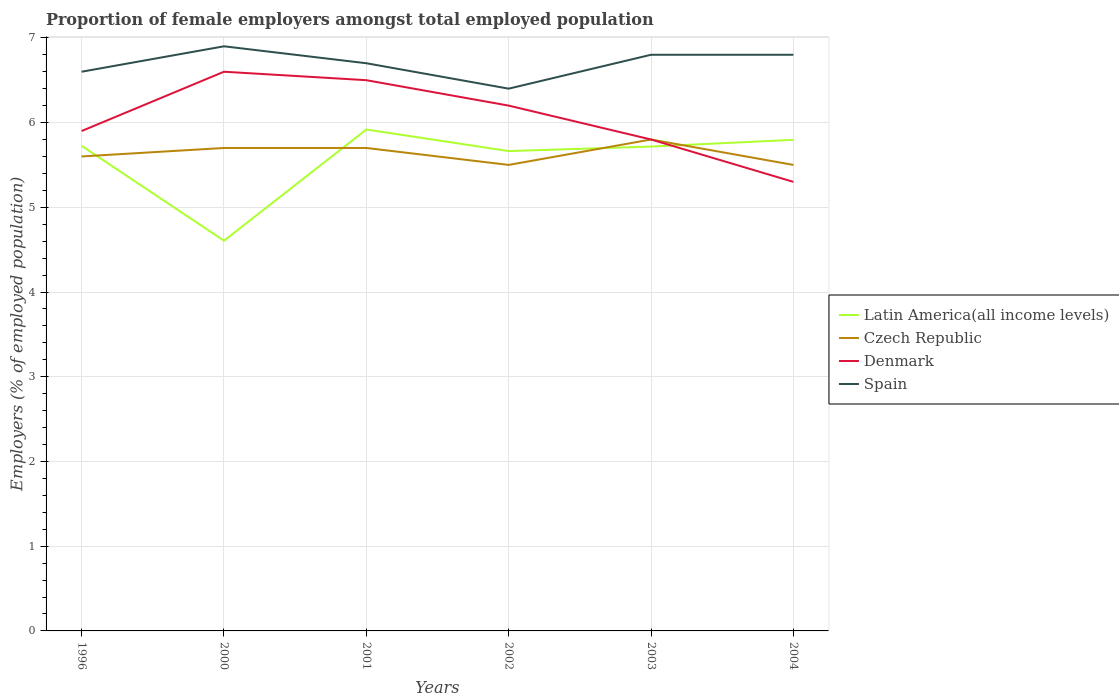Across all years, what is the maximum proportion of female employers in Denmark?
Keep it short and to the point. 5.3. In which year was the proportion of female employers in Denmark maximum?
Give a very brief answer. 2004. What is the total proportion of female employers in Czech Republic in the graph?
Your answer should be very brief. 0.2. What is the difference between the highest and the second highest proportion of female employers in Czech Republic?
Keep it short and to the point. 0.3. What is the difference between the highest and the lowest proportion of female employers in Spain?
Provide a short and direct response. 3. How many lines are there?
Your answer should be compact. 4. How many years are there in the graph?
Keep it short and to the point. 6. Does the graph contain any zero values?
Provide a short and direct response. No. How many legend labels are there?
Provide a short and direct response. 4. What is the title of the graph?
Provide a succinct answer. Proportion of female employers amongst total employed population. Does "Mali" appear as one of the legend labels in the graph?
Give a very brief answer. No. What is the label or title of the Y-axis?
Offer a terse response. Employers (% of employed population). What is the Employers (% of employed population) in Latin America(all income levels) in 1996?
Offer a very short reply. 5.73. What is the Employers (% of employed population) in Czech Republic in 1996?
Keep it short and to the point. 5.6. What is the Employers (% of employed population) in Denmark in 1996?
Offer a terse response. 5.9. What is the Employers (% of employed population) in Spain in 1996?
Give a very brief answer. 6.6. What is the Employers (% of employed population) of Latin America(all income levels) in 2000?
Offer a very short reply. 4.61. What is the Employers (% of employed population) of Czech Republic in 2000?
Provide a succinct answer. 5.7. What is the Employers (% of employed population) of Denmark in 2000?
Keep it short and to the point. 6.6. What is the Employers (% of employed population) of Spain in 2000?
Offer a very short reply. 6.9. What is the Employers (% of employed population) in Latin America(all income levels) in 2001?
Provide a short and direct response. 5.92. What is the Employers (% of employed population) in Czech Republic in 2001?
Ensure brevity in your answer.  5.7. What is the Employers (% of employed population) of Denmark in 2001?
Make the answer very short. 6.5. What is the Employers (% of employed population) in Spain in 2001?
Offer a terse response. 6.7. What is the Employers (% of employed population) of Latin America(all income levels) in 2002?
Ensure brevity in your answer.  5.66. What is the Employers (% of employed population) of Czech Republic in 2002?
Keep it short and to the point. 5.5. What is the Employers (% of employed population) of Denmark in 2002?
Give a very brief answer. 6.2. What is the Employers (% of employed population) in Spain in 2002?
Keep it short and to the point. 6.4. What is the Employers (% of employed population) of Latin America(all income levels) in 2003?
Your answer should be very brief. 5.72. What is the Employers (% of employed population) in Czech Republic in 2003?
Offer a very short reply. 5.8. What is the Employers (% of employed population) of Denmark in 2003?
Offer a terse response. 5.8. What is the Employers (% of employed population) of Spain in 2003?
Your answer should be compact. 6.8. What is the Employers (% of employed population) of Latin America(all income levels) in 2004?
Provide a short and direct response. 5.8. What is the Employers (% of employed population) of Czech Republic in 2004?
Your answer should be compact. 5.5. What is the Employers (% of employed population) in Denmark in 2004?
Your response must be concise. 5.3. What is the Employers (% of employed population) of Spain in 2004?
Offer a very short reply. 6.8. Across all years, what is the maximum Employers (% of employed population) of Latin America(all income levels)?
Your answer should be very brief. 5.92. Across all years, what is the maximum Employers (% of employed population) in Czech Republic?
Your response must be concise. 5.8. Across all years, what is the maximum Employers (% of employed population) of Denmark?
Make the answer very short. 6.6. Across all years, what is the maximum Employers (% of employed population) in Spain?
Provide a succinct answer. 6.9. Across all years, what is the minimum Employers (% of employed population) of Latin America(all income levels)?
Your answer should be compact. 4.61. Across all years, what is the minimum Employers (% of employed population) in Denmark?
Your answer should be compact. 5.3. Across all years, what is the minimum Employers (% of employed population) of Spain?
Your answer should be compact. 6.4. What is the total Employers (% of employed population) of Latin America(all income levels) in the graph?
Your answer should be very brief. 33.43. What is the total Employers (% of employed population) in Czech Republic in the graph?
Your answer should be very brief. 33.8. What is the total Employers (% of employed population) of Denmark in the graph?
Your response must be concise. 36.3. What is the total Employers (% of employed population) of Spain in the graph?
Offer a terse response. 40.2. What is the difference between the Employers (% of employed population) in Latin America(all income levels) in 1996 and that in 2000?
Your response must be concise. 1.12. What is the difference between the Employers (% of employed population) in Denmark in 1996 and that in 2000?
Keep it short and to the point. -0.7. What is the difference between the Employers (% of employed population) in Spain in 1996 and that in 2000?
Your response must be concise. -0.3. What is the difference between the Employers (% of employed population) of Latin America(all income levels) in 1996 and that in 2001?
Keep it short and to the point. -0.19. What is the difference between the Employers (% of employed population) in Denmark in 1996 and that in 2001?
Your response must be concise. -0.6. What is the difference between the Employers (% of employed population) in Latin America(all income levels) in 1996 and that in 2002?
Your answer should be compact. 0.06. What is the difference between the Employers (% of employed population) in Latin America(all income levels) in 1996 and that in 2003?
Your response must be concise. 0.01. What is the difference between the Employers (% of employed population) of Denmark in 1996 and that in 2003?
Keep it short and to the point. 0.1. What is the difference between the Employers (% of employed population) in Spain in 1996 and that in 2003?
Make the answer very short. -0.2. What is the difference between the Employers (% of employed population) in Latin America(all income levels) in 1996 and that in 2004?
Offer a terse response. -0.07. What is the difference between the Employers (% of employed population) in Denmark in 1996 and that in 2004?
Your response must be concise. 0.6. What is the difference between the Employers (% of employed population) in Latin America(all income levels) in 2000 and that in 2001?
Your answer should be compact. -1.31. What is the difference between the Employers (% of employed population) of Spain in 2000 and that in 2001?
Offer a very short reply. 0.2. What is the difference between the Employers (% of employed population) in Latin America(all income levels) in 2000 and that in 2002?
Keep it short and to the point. -1.06. What is the difference between the Employers (% of employed population) of Czech Republic in 2000 and that in 2002?
Offer a very short reply. 0.2. What is the difference between the Employers (% of employed population) of Denmark in 2000 and that in 2002?
Provide a succinct answer. 0.4. What is the difference between the Employers (% of employed population) in Latin America(all income levels) in 2000 and that in 2003?
Keep it short and to the point. -1.11. What is the difference between the Employers (% of employed population) of Latin America(all income levels) in 2000 and that in 2004?
Ensure brevity in your answer.  -1.19. What is the difference between the Employers (% of employed population) of Latin America(all income levels) in 2001 and that in 2002?
Give a very brief answer. 0.25. What is the difference between the Employers (% of employed population) of Denmark in 2001 and that in 2002?
Your response must be concise. 0.3. What is the difference between the Employers (% of employed population) in Latin America(all income levels) in 2001 and that in 2003?
Your answer should be compact. 0.2. What is the difference between the Employers (% of employed population) in Latin America(all income levels) in 2001 and that in 2004?
Keep it short and to the point. 0.12. What is the difference between the Employers (% of employed population) in Czech Republic in 2001 and that in 2004?
Provide a short and direct response. 0.2. What is the difference between the Employers (% of employed population) of Spain in 2001 and that in 2004?
Provide a succinct answer. -0.1. What is the difference between the Employers (% of employed population) in Latin America(all income levels) in 2002 and that in 2003?
Provide a succinct answer. -0.05. What is the difference between the Employers (% of employed population) in Czech Republic in 2002 and that in 2003?
Keep it short and to the point. -0.3. What is the difference between the Employers (% of employed population) of Spain in 2002 and that in 2003?
Ensure brevity in your answer.  -0.4. What is the difference between the Employers (% of employed population) of Latin America(all income levels) in 2002 and that in 2004?
Keep it short and to the point. -0.13. What is the difference between the Employers (% of employed population) in Denmark in 2002 and that in 2004?
Your response must be concise. 0.9. What is the difference between the Employers (% of employed population) of Latin America(all income levels) in 2003 and that in 2004?
Your answer should be very brief. -0.08. What is the difference between the Employers (% of employed population) in Latin America(all income levels) in 1996 and the Employers (% of employed population) in Czech Republic in 2000?
Your answer should be very brief. 0.03. What is the difference between the Employers (% of employed population) of Latin America(all income levels) in 1996 and the Employers (% of employed population) of Denmark in 2000?
Offer a very short reply. -0.87. What is the difference between the Employers (% of employed population) in Latin America(all income levels) in 1996 and the Employers (% of employed population) in Spain in 2000?
Offer a terse response. -1.17. What is the difference between the Employers (% of employed population) in Czech Republic in 1996 and the Employers (% of employed population) in Spain in 2000?
Your answer should be very brief. -1.3. What is the difference between the Employers (% of employed population) of Denmark in 1996 and the Employers (% of employed population) of Spain in 2000?
Your answer should be very brief. -1. What is the difference between the Employers (% of employed population) of Latin America(all income levels) in 1996 and the Employers (% of employed population) of Czech Republic in 2001?
Provide a succinct answer. 0.03. What is the difference between the Employers (% of employed population) in Latin America(all income levels) in 1996 and the Employers (% of employed population) in Denmark in 2001?
Provide a short and direct response. -0.77. What is the difference between the Employers (% of employed population) in Latin America(all income levels) in 1996 and the Employers (% of employed population) in Spain in 2001?
Give a very brief answer. -0.97. What is the difference between the Employers (% of employed population) of Czech Republic in 1996 and the Employers (% of employed population) of Denmark in 2001?
Offer a very short reply. -0.9. What is the difference between the Employers (% of employed population) of Latin America(all income levels) in 1996 and the Employers (% of employed population) of Czech Republic in 2002?
Ensure brevity in your answer.  0.23. What is the difference between the Employers (% of employed population) in Latin America(all income levels) in 1996 and the Employers (% of employed population) in Denmark in 2002?
Keep it short and to the point. -0.47. What is the difference between the Employers (% of employed population) of Latin America(all income levels) in 1996 and the Employers (% of employed population) of Spain in 2002?
Make the answer very short. -0.67. What is the difference between the Employers (% of employed population) of Czech Republic in 1996 and the Employers (% of employed population) of Spain in 2002?
Your answer should be very brief. -0.8. What is the difference between the Employers (% of employed population) in Denmark in 1996 and the Employers (% of employed population) in Spain in 2002?
Provide a succinct answer. -0.5. What is the difference between the Employers (% of employed population) of Latin America(all income levels) in 1996 and the Employers (% of employed population) of Czech Republic in 2003?
Keep it short and to the point. -0.07. What is the difference between the Employers (% of employed population) of Latin America(all income levels) in 1996 and the Employers (% of employed population) of Denmark in 2003?
Your answer should be compact. -0.07. What is the difference between the Employers (% of employed population) in Latin America(all income levels) in 1996 and the Employers (% of employed population) in Spain in 2003?
Your answer should be very brief. -1.07. What is the difference between the Employers (% of employed population) of Czech Republic in 1996 and the Employers (% of employed population) of Spain in 2003?
Your answer should be compact. -1.2. What is the difference between the Employers (% of employed population) in Latin America(all income levels) in 1996 and the Employers (% of employed population) in Czech Republic in 2004?
Provide a succinct answer. 0.23. What is the difference between the Employers (% of employed population) of Latin America(all income levels) in 1996 and the Employers (% of employed population) of Denmark in 2004?
Offer a terse response. 0.43. What is the difference between the Employers (% of employed population) in Latin America(all income levels) in 1996 and the Employers (% of employed population) in Spain in 2004?
Make the answer very short. -1.07. What is the difference between the Employers (% of employed population) of Latin America(all income levels) in 2000 and the Employers (% of employed population) of Czech Republic in 2001?
Offer a very short reply. -1.09. What is the difference between the Employers (% of employed population) in Latin America(all income levels) in 2000 and the Employers (% of employed population) in Denmark in 2001?
Keep it short and to the point. -1.89. What is the difference between the Employers (% of employed population) of Latin America(all income levels) in 2000 and the Employers (% of employed population) of Spain in 2001?
Your answer should be compact. -2.09. What is the difference between the Employers (% of employed population) in Czech Republic in 2000 and the Employers (% of employed population) in Spain in 2001?
Provide a succinct answer. -1. What is the difference between the Employers (% of employed population) of Latin America(all income levels) in 2000 and the Employers (% of employed population) of Czech Republic in 2002?
Ensure brevity in your answer.  -0.89. What is the difference between the Employers (% of employed population) in Latin America(all income levels) in 2000 and the Employers (% of employed population) in Denmark in 2002?
Offer a very short reply. -1.59. What is the difference between the Employers (% of employed population) of Latin America(all income levels) in 2000 and the Employers (% of employed population) of Spain in 2002?
Provide a short and direct response. -1.79. What is the difference between the Employers (% of employed population) of Czech Republic in 2000 and the Employers (% of employed population) of Denmark in 2002?
Ensure brevity in your answer.  -0.5. What is the difference between the Employers (% of employed population) in Czech Republic in 2000 and the Employers (% of employed population) in Spain in 2002?
Give a very brief answer. -0.7. What is the difference between the Employers (% of employed population) of Denmark in 2000 and the Employers (% of employed population) of Spain in 2002?
Ensure brevity in your answer.  0.2. What is the difference between the Employers (% of employed population) in Latin America(all income levels) in 2000 and the Employers (% of employed population) in Czech Republic in 2003?
Give a very brief answer. -1.19. What is the difference between the Employers (% of employed population) of Latin America(all income levels) in 2000 and the Employers (% of employed population) of Denmark in 2003?
Make the answer very short. -1.19. What is the difference between the Employers (% of employed population) in Latin America(all income levels) in 2000 and the Employers (% of employed population) in Spain in 2003?
Provide a succinct answer. -2.19. What is the difference between the Employers (% of employed population) in Czech Republic in 2000 and the Employers (% of employed population) in Denmark in 2003?
Your answer should be compact. -0.1. What is the difference between the Employers (% of employed population) of Latin America(all income levels) in 2000 and the Employers (% of employed population) of Czech Republic in 2004?
Offer a very short reply. -0.89. What is the difference between the Employers (% of employed population) of Latin America(all income levels) in 2000 and the Employers (% of employed population) of Denmark in 2004?
Your response must be concise. -0.69. What is the difference between the Employers (% of employed population) of Latin America(all income levels) in 2000 and the Employers (% of employed population) of Spain in 2004?
Give a very brief answer. -2.19. What is the difference between the Employers (% of employed population) of Czech Republic in 2000 and the Employers (% of employed population) of Denmark in 2004?
Keep it short and to the point. 0.4. What is the difference between the Employers (% of employed population) in Latin America(all income levels) in 2001 and the Employers (% of employed population) in Czech Republic in 2002?
Your response must be concise. 0.42. What is the difference between the Employers (% of employed population) in Latin America(all income levels) in 2001 and the Employers (% of employed population) in Denmark in 2002?
Offer a very short reply. -0.28. What is the difference between the Employers (% of employed population) in Latin America(all income levels) in 2001 and the Employers (% of employed population) in Spain in 2002?
Your answer should be compact. -0.48. What is the difference between the Employers (% of employed population) in Czech Republic in 2001 and the Employers (% of employed population) in Spain in 2002?
Offer a very short reply. -0.7. What is the difference between the Employers (% of employed population) in Latin America(all income levels) in 2001 and the Employers (% of employed population) in Czech Republic in 2003?
Your answer should be very brief. 0.12. What is the difference between the Employers (% of employed population) in Latin America(all income levels) in 2001 and the Employers (% of employed population) in Denmark in 2003?
Keep it short and to the point. 0.12. What is the difference between the Employers (% of employed population) in Latin America(all income levels) in 2001 and the Employers (% of employed population) in Spain in 2003?
Ensure brevity in your answer.  -0.88. What is the difference between the Employers (% of employed population) in Czech Republic in 2001 and the Employers (% of employed population) in Spain in 2003?
Offer a terse response. -1.1. What is the difference between the Employers (% of employed population) in Latin America(all income levels) in 2001 and the Employers (% of employed population) in Czech Republic in 2004?
Offer a very short reply. 0.42. What is the difference between the Employers (% of employed population) in Latin America(all income levels) in 2001 and the Employers (% of employed population) in Denmark in 2004?
Your response must be concise. 0.62. What is the difference between the Employers (% of employed population) in Latin America(all income levels) in 2001 and the Employers (% of employed population) in Spain in 2004?
Offer a very short reply. -0.88. What is the difference between the Employers (% of employed population) in Czech Republic in 2001 and the Employers (% of employed population) in Denmark in 2004?
Give a very brief answer. 0.4. What is the difference between the Employers (% of employed population) in Latin America(all income levels) in 2002 and the Employers (% of employed population) in Czech Republic in 2003?
Ensure brevity in your answer.  -0.14. What is the difference between the Employers (% of employed population) in Latin America(all income levels) in 2002 and the Employers (% of employed population) in Denmark in 2003?
Give a very brief answer. -0.14. What is the difference between the Employers (% of employed population) of Latin America(all income levels) in 2002 and the Employers (% of employed population) of Spain in 2003?
Your response must be concise. -1.14. What is the difference between the Employers (% of employed population) of Czech Republic in 2002 and the Employers (% of employed population) of Spain in 2003?
Offer a very short reply. -1.3. What is the difference between the Employers (% of employed population) of Latin America(all income levels) in 2002 and the Employers (% of employed population) of Czech Republic in 2004?
Give a very brief answer. 0.16. What is the difference between the Employers (% of employed population) in Latin America(all income levels) in 2002 and the Employers (% of employed population) in Denmark in 2004?
Offer a very short reply. 0.36. What is the difference between the Employers (% of employed population) in Latin America(all income levels) in 2002 and the Employers (% of employed population) in Spain in 2004?
Offer a terse response. -1.14. What is the difference between the Employers (% of employed population) of Latin America(all income levels) in 2003 and the Employers (% of employed population) of Czech Republic in 2004?
Your answer should be very brief. 0.22. What is the difference between the Employers (% of employed population) of Latin America(all income levels) in 2003 and the Employers (% of employed population) of Denmark in 2004?
Ensure brevity in your answer.  0.42. What is the difference between the Employers (% of employed population) of Latin America(all income levels) in 2003 and the Employers (% of employed population) of Spain in 2004?
Offer a terse response. -1.08. What is the difference between the Employers (% of employed population) in Denmark in 2003 and the Employers (% of employed population) in Spain in 2004?
Make the answer very short. -1. What is the average Employers (% of employed population) of Latin America(all income levels) per year?
Make the answer very short. 5.57. What is the average Employers (% of employed population) in Czech Republic per year?
Offer a very short reply. 5.63. What is the average Employers (% of employed population) of Denmark per year?
Ensure brevity in your answer.  6.05. What is the average Employers (% of employed population) of Spain per year?
Ensure brevity in your answer.  6.7. In the year 1996, what is the difference between the Employers (% of employed population) in Latin America(all income levels) and Employers (% of employed population) in Czech Republic?
Provide a short and direct response. 0.13. In the year 1996, what is the difference between the Employers (% of employed population) in Latin America(all income levels) and Employers (% of employed population) in Denmark?
Offer a very short reply. -0.17. In the year 1996, what is the difference between the Employers (% of employed population) in Latin America(all income levels) and Employers (% of employed population) in Spain?
Your response must be concise. -0.87. In the year 1996, what is the difference between the Employers (% of employed population) in Czech Republic and Employers (% of employed population) in Denmark?
Your response must be concise. -0.3. In the year 1996, what is the difference between the Employers (% of employed population) of Denmark and Employers (% of employed population) of Spain?
Provide a succinct answer. -0.7. In the year 2000, what is the difference between the Employers (% of employed population) of Latin America(all income levels) and Employers (% of employed population) of Czech Republic?
Make the answer very short. -1.09. In the year 2000, what is the difference between the Employers (% of employed population) in Latin America(all income levels) and Employers (% of employed population) in Denmark?
Make the answer very short. -1.99. In the year 2000, what is the difference between the Employers (% of employed population) of Latin America(all income levels) and Employers (% of employed population) of Spain?
Your answer should be compact. -2.29. In the year 2000, what is the difference between the Employers (% of employed population) of Czech Republic and Employers (% of employed population) of Denmark?
Ensure brevity in your answer.  -0.9. In the year 2000, what is the difference between the Employers (% of employed population) of Denmark and Employers (% of employed population) of Spain?
Keep it short and to the point. -0.3. In the year 2001, what is the difference between the Employers (% of employed population) of Latin America(all income levels) and Employers (% of employed population) of Czech Republic?
Ensure brevity in your answer.  0.22. In the year 2001, what is the difference between the Employers (% of employed population) of Latin America(all income levels) and Employers (% of employed population) of Denmark?
Provide a succinct answer. -0.58. In the year 2001, what is the difference between the Employers (% of employed population) in Latin America(all income levels) and Employers (% of employed population) in Spain?
Provide a short and direct response. -0.78. In the year 2001, what is the difference between the Employers (% of employed population) of Czech Republic and Employers (% of employed population) of Denmark?
Make the answer very short. -0.8. In the year 2001, what is the difference between the Employers (% of employed population) in Czech Republic and Employers (% of employed population) in Spain?
Offer a terse response. -1. In the year 2002, what is the difference between the Employers (% of employed population) of Latin America(all income levels) and Employers (% of employed population) of Czech Republic?
Offer a terse response. 0.16. In the year 2002, what is the difference between the Employers (% of employed population) in Latin America(all income levels) and Employers (% of employed population) in Denmark?
Make the answer very short. -0.54. In the year 2002, what is the difference between the Employers (% of employed population) in Latin America(all income levels) and Employers (% of employed population) in Spain?
Your response must be concise. -0.74. In the year 2002, what is the difference between the Employers (% of employed population) of Czech Republic and Employers (% of employed population) of Denmark?
Keep it short and to the point. -0.7. In the year 2002, what is the difference between the Employers (% of employed population) in Denmark and Employers (% of employed population) in Spain?
Give a very brief answer. -0.2. In the year 2003, what is the difference between the Employers (% of employed population) of Latin America(all income levels) and Employers (% of employed population) of Czech Republic?
Make the answer very short. -0.08. In the year 2003, what is the difference between the Employers (% of employed population) in Latin America(all income levels) and Employers (% of employed population) in Denmark?
Ensure brevity in your answer.  -0.08. In the year 2003, what is the difference between the Employers (% of employed population) of Latin America(all income levels) and Employers (% of employed population) of Spain?
Provide a short and direct response. -1.08. In the year 2003, what is the difference between the Employers (% of employed population) of Czech Republic and Employers (% of employed population) of Denmark?
Your answer should be very brief. 0. In the year 2003, what is the difference between the Employers (% of employed population) of Denmark and Employers (% of employed population) of Spain?
Make the answer very short. -1. In the year 2004, what is the difference between the Employers (% of employed population) in Latin America(all income levels) and Employers (% of employed population) in Czech Republic?
Offer a very short reply. 0.3. In the year 2004, what is the difference between the Employers (% of employed population) of Latin America(all income levels) and Employers (% of employed population) of Denmark?
Your response must be concise. 0.5. In the year 2004, what is the difference between the Employers (% of employed population) of Latin America(all income levels) and Employers (% of employed population) of Spain?
Provide a succinct answer. -1. What is the ratio of the Employers (% of employed population) of Latin America(all income levels) in 1996 to that in 2000?
Give a very brief answer. 1.24. What is the ratio of the Employers (% of employed population) in Czech Republic in 1996 to that in 2000?
Provide a short and direct response. 0.98. What is the ratio of the Employers (% of employed population) of Denmark in 1996 to that in 2000?
Provide a succinct answer. 0.89. What is the ratio of the Employers (% of employed population) in Spain in 1996 to that in 2000?
Give a very brief answer. 0.96. What is the ratio of the Employers (% of employed population) in Latin America(all income levels) in 1996 to that in 2001?
Keep it short and to the point. 0.97. What is the ratio of the Employers (% of employed population) of Czech Republic in 1996 to that in 2001?
Ensure brevity in your answer.  0.98. What is the ratio of the Employers (% of employed population) of Denmark in 1996 to that in 2001?
Ensure brevity in your answer.  0.91. What is the ratio of the Employers (% of employed population) in Spain in 1996 to that in 2001?
Provide a short and direct response. 0.99. What is the ratio of the Employers (% of employed population) in Czech Republic in 1996 to that in 2002?
Your response must be concise. 1.02. What is the ratio of the Employers (% of employed population) of Denmark in 1996 to that in 2002?
Ensure brevity in your answer.  0.95. What is the ratio of the Employers (% of employed population) of Spain in 1996 to that in 2002?
Make the answer very short. 1.03. What is the ratio of the Employers (% of employed population) in Czech Republic in 1996 to that in 2003?
Your answer should be very brief. 0.97. What is the ratio of the Employers (% of employed population) in Denmark in 1996 to that in 2003?
Provide a short and direct response. 1.02. What is the ratio of the Employers (% of employed population) in Spain in 1996 to that in 2003?
Provide a short and direct response. 0.97. What is the ratio of the Employers (% of employed population) of Latin America(all income levels) in 1996 to that in 2004?
Make the answer very short. 0.99. What is the ratio of the Employers (% of employed population) of Czech Republic in 1996 to that in 2004?
Your answer should be very brief. 1.02. What is the ratio of the Employers (% of employed population) of Denmark in 1996 to that in 2004?
Your answer should be compact. 1.11. What is the ratio of the Employers (% of employed population) in Spain in 1996 to that in 2004?
Your answer should be very brief. 0.97. What is the ratio of the Employers (% of employed population) in Latin America(all income levels) in 2000 to that in 2001?
Keep it short and to the point. 0.78. What is the ratio of the Employers (% of employed population) in Czech Republic in 2000 to that in 2001?
Provide a succinct answer. 1. What is the ratio of the Employers (% of employed population) of Denmark in 2000 to that in 2001?
Give a very brief answer. 1.02. What is the ratio of the Employers (% of employed population) of Spain in 2000 to that in 2001?
Make the answer very short. 1.03. What is the ratio of the Employers (% of employed population) in Latin America(all income levels) in 2000 to that in 2002?
Keep it short and to the point. 0.81. What is the ratio of the Employers (% of employed population) in Czech Republic in 2000 to that in 2002?
Offer a terse response. 1.04. What is the ratio of the Employers (% of employed population) of Denmark in 2000 to that in 2002?
Provide a succinct answer. 1.06. What is the ratio of the Employers (% of employed population) of Spain in 2000 to that in 2002?
Offer a terse response. 1.08. What is the ratio of the Employers (% of employed population) of Latin America(all income levels) in 2000 to that in 2003?
Ensure brevity in your answer.  0.81. What is the ratio of the Employers (% of employed population) in Czech Republic in 2000 to that in 2003?
Give a very brief answer. 0.98. What is the ratio of the Employers (% of employed population) in Denmark in 2000 to that in 2003?
Offer a terse response. 1.14. What is the ratio of the Employers (% of employed population) in Spain in 2000 to that in 2003?
Offer a very short reply. 1.01. What is the ratio of the Employers (% of employed population) in Latin America(all income levels) in 2000 to that in 2004?
Offer a terse response. 0.79. What is the ratio of the Employers (% of employed population) in Czech Republic in 2000 to that in 2004?
Your answer should be compact. 1.04. What is the ratio of the Employers (% of employed population) in Denmark in 2000 to that in 2004?
Your answer should be compact. 1.25. What is the ratio of the Employers (% of employed population) in Spain in 2000 to that in 2004?
Offer a terse response. 1.01. What is the ratio of the Employers (% of employed population) in Latin America(all income levels) in 2001 to that in 2002?
Your answer should be compact. 1.04. What is the ratio of the Employers (% of employed population) in Czech Republic in 2001 to that in 2002?
Offer a terse response. 1.04. What is the ratio of the Employers (% of employed population) of Denmark in 2001 to that in 2002?
Give a very brief answer. 1.05. What is the ratio of the Employers (% of employed population) of Spain in 2001 to that in 2002?
Provide a succinct answer. 1.05. What is the ratio of the Employers (% of employed population) in Latin America(all income levels) in 2001 to that in 2003?
Your answer should be compact. 1.04. What is the ratio of the Employers (% of employed population) of Czech Republic in 2001 to that in 2003?
Offer a terse response. 0.98. What is the ratio of the Employers (% of employed population) in Denmark in 2001 to that in 2003?
Provide a short and direct response. 1.12. What is the ratio of the Employers (% of employed population) in Spain in 2001 to that in 2003?
Give a very brief answer. 0.99. What is the ratio of the Employers (% of employed population) in Latin America(all income levels) in 2001 to that in 2004?
Provide a succinct answer. 1.02. What is the ratio of the Employers (% of employed population) in Czech Republic in 2001 to that in 2004?
Your answer should be very brief. 1.04. What is the ratio of the Employers (% of employed population) of Denmark in 2001 to that in 2004?
Offer a terse response. 1.23. What is the ratio of the Employers (% of employed population) of Spain in 2001 to that in 2004?
Keep it short and to the point. 0.99. What is the ratio of the Employers (% of employed population) in Czech Republic in 2002 to that in 2003?
Your answer should be compact. 0.95. What is the ratio of the Employers (% of employed population) in Denmark in 2002 to that in 2003?
Make the answer very short. 1.07. What is the ratio of the Employers (% of employed population) in Spain in 2002 to that in 2003?
Your answer should be very brief. 0.94. What is the ratio of the Employers (% of employed population) of Latin America(all income levels) in 2002 to that in 2004?
Make the answer very short. 0.98. What is the ratio of the Employers (% of employed population) of Czech Republic in 2002 to that in 2004?
Keep it short and to the point. 1. What is the ratio of the Employers (% of employed population) of Denmark in 2002 to that in 2004?
Keep it short and to the point. 1.17. What is the ratio of the Employers (% of employed population) of Latin America(all income levels) in 2003 to that in 2004?
Make the answer very short. 0.99. What is the ratio of the Employers (% of employed population) of Czech Republic in 2003 to that in 2004?
Your answer should be compact. 1.05. What is the ratio of the Employers (% of employed population) in Denmark in 2003 to that in 2004?
Ensure brevity in your answer.  1.09. What is the difference between the highest and the second highest Employers (% of employed population) in Latin America(all income levels)?
Ensure brevity in your answer.  0.12. What is the difference between the highest and the second highest Employers (% of employed population) in Spain?
Provide a short and direct response. 0.1. What is the difference between the highest and the lowest Employers (% of employed population) of Latin America(all income levels)?
Provide a short and direct response. 1.31. What is the difference between the highest and the lowest Employers (% of employed population) in Czech Republic?
Provide a short and direct response. 0.3. 